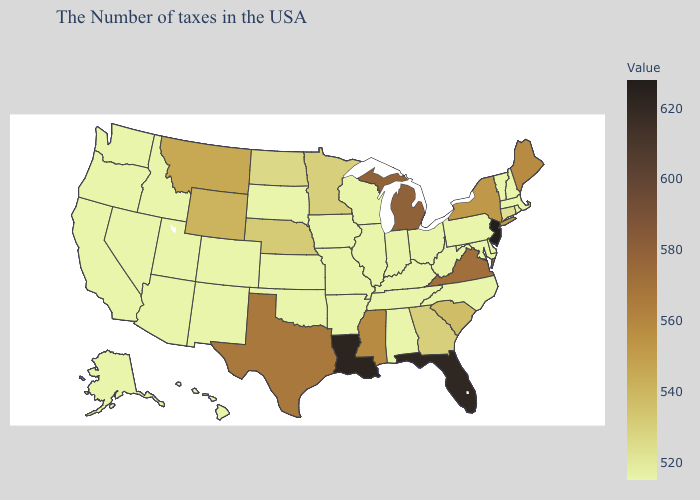Which states have the lowest value in the South?
Short answer required. Delaware, Maryland, North Carolina, West Virginia, Kentucky, Alabama, Tennessee, Arkansas, Oklahoma. Which states hav the highest value in the South?
Short answer required. Louisiana. Does Indiana have the highest value in the USA?
Give a very brief answer. No. Among the states that border North Dakota , which have the lowest value?
Short answer required. South Dakota. Does the map have missing data?
Keep it brief. No. Which states have the lowest value in the MidWest?
Write a very short answer. Ohio, Indiana, Wisconsin, Illinois, Missouri, Iowa, Kansas, South Dakota. 